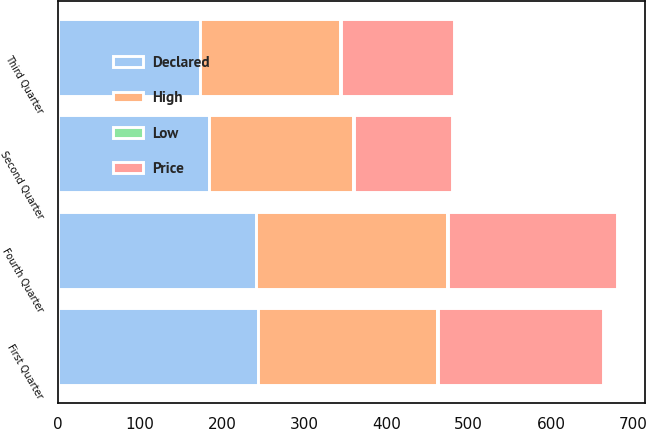Convert chart to OTSL. <chart><loc_0><loc_0><loc_500><loc_500><stacked_bar_chart><ecel><fcel>First Quarter<fcel>Third Quarter<fcel>Second Quarter<fcel>Fourth Quarter<nl><fcel>Declared<fcel>243.8<fcel>172.87<fcel>183.8<fcel>241.66<nl><fcel>Price<fcel>200.56<fcel>138.42<fcel>119.12<fcel>206<nl><fcel>High<fcel>217.76<fcel>170.25<fcel>175.42<fcel>232.2<nl><fcel>Low<fcel>1<fcel>1<fcel>0.78<fcel>0.78<nl></chart> 